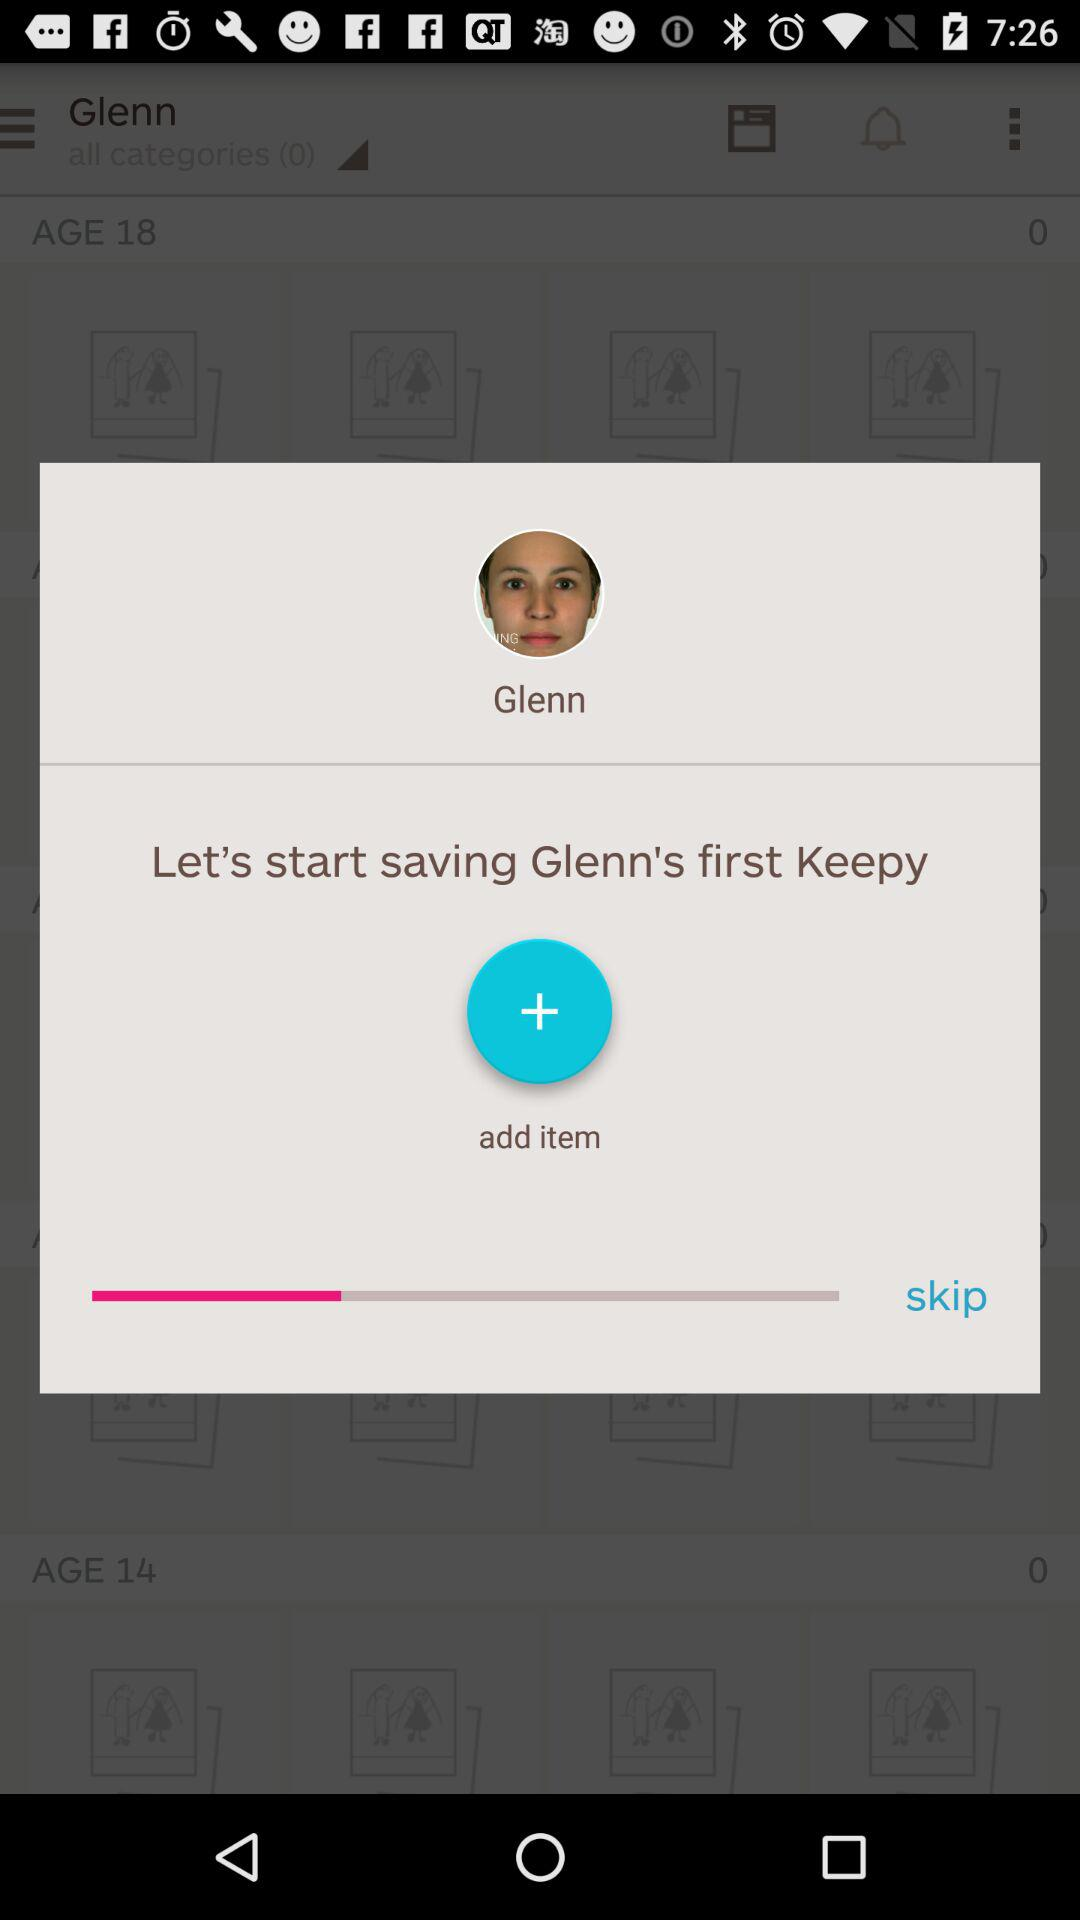What is the name of the user? The user name is Glenn. 